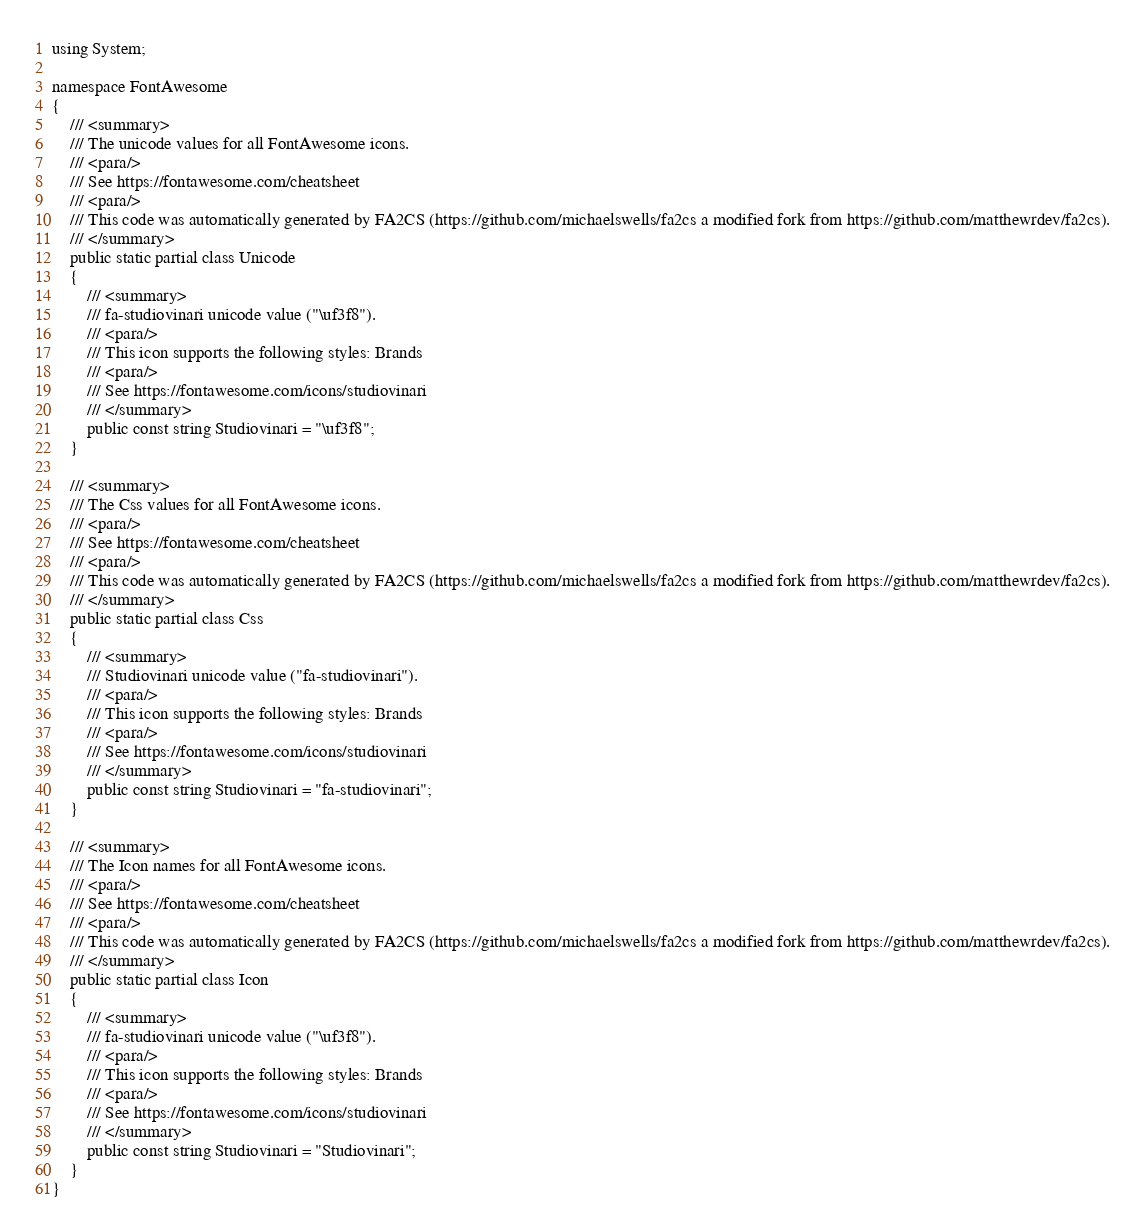Convert code to text. <code><loc_0><loc_0><loc_500><loc_500><_C#_>using System;

namespace FontAwesome
{
    /// <summary>
    /// The unicode values for all FontAwesome icons.
    /// <para/>
    /// See https://fontawesome.com/cheatsheet
    /// <para/>
    /// This code was automatically generated by FA2CS (https://github.com/michaelswells/fa2cs a modified fork from https://github.com/matthewrdev/fa2cs).
    /// </summary>
    public static partial class Unicode
    {
        /// <summary>
        /// fa-studiovinari unicode value ("\uf3f8").
        /// <para/>
        /// This icon supports the following styles: Brands
        /// <para/>
        /// See https://fontawesome.com/icons/studiovinari
        /// </summary>
        public const string Studiovinari = "\uf3f8";
    }

    /// <summary>
    /// The Css values for all FontAwesome icons.
    /// <para/>
    /// See https://fontawesome.com/cheatsheet
    /// <para/>
    /// This code was automatically generated by FA2CS (https://github.com/michaelswells/fa2cs a modified fork from https://github.com/matthewrdev/fa2cs).
    /// </summary>
    public static partial class Css
    {
        /// <summary>
        /// Studiovinari unicode value ("fa-studiovinari").
        /// <para/>
        /// This icon supports the following styles: Brands
        /// <para/>
        /// See https://fontawesome.com/icons/studiovinari
        /// </summary>
        public const string Studiovinari = "fa-studiovinari";
    }

    /// <summary>
    /// The Icon names for all FontAwesome icons.
    /// <para/>
    /// See https://fontawesome.com/cheatsheet
    /// <para/>
    /// This code was automatically generated by FA2CS (https://github.com/michaelswells/fa2cs a modified fork from https://github.com/matthewrdev/fa2cs).
    /// </summary>
    public static partial class Icon
    {
        /// <summary>
        /// fa-studiovinari unicode value ("\uf3f8").
        /// <para/>
        /// This icon supports the following styles: Brands
        /// <para/>
        /// See https://fontawesome.com/icons/studiovinari
        /// </summary>
        public const string Studiovinari = "Studiovinari";
    }
}</code> 